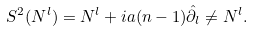<formula> <loc_0><loc_0><loc_500><loc_500>S ^ { 2 } ( N ^ { l } ) = N ^ { l } + i a ( n - 1 ) \hat { \partial } _ { l } \ne N ^ { l } .</formula> 